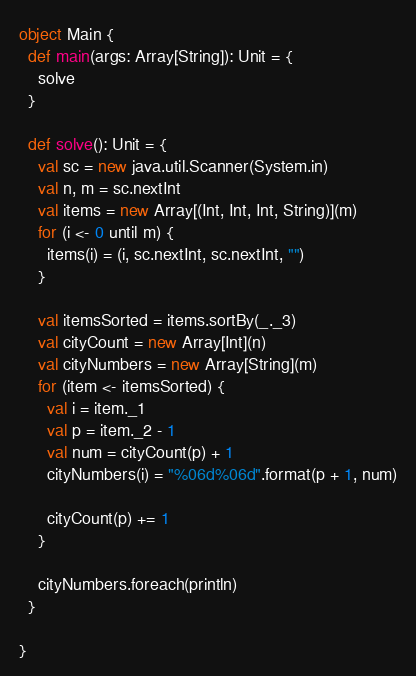Convert code to text. <code><loc_0><loc_0><loc_500><loc_500><_Scala_>object Main {
  def main(args: Array[String]): Unit = {
    solve
  }

  def solve(): Unit = {
    val sc = new java.util.Scanner(System.in)
    val n, m = sc.nextInt
    val items = new Array[(Int, Int, Int, String)](m)
    for (i <- 0 until m) {
      items(i) = (i, sc.nextInt, sc.nextInt, "")
    }

    val itemsSorted = items.sortBy(_._3)
    val cityCount = new Array[Int](n)
    val cityNumbers = new Array[String](m)
    for (item <- itemsSorted) {
      val i = item._1
      val p = item._2 - 1
      val num = cityCount(p) + 1
      cityNumbers(i) = "%06d%06d".format(p + 1, num)

      cityCount(p) += 1
    }

    cityNumbers.foreach(println)
  }

}
</code> 